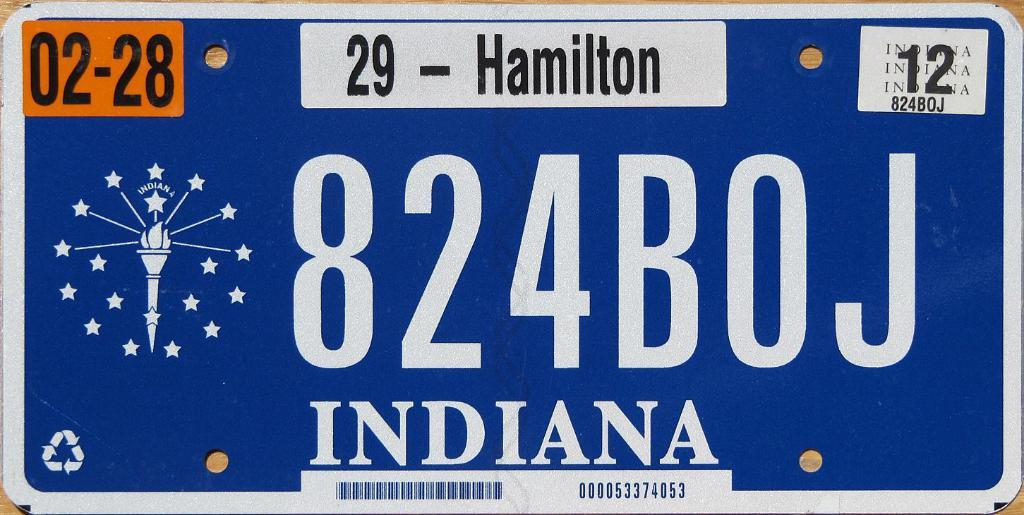Provide a one-sentence caption for the provided image. the state of Indiana is on a license plate. 